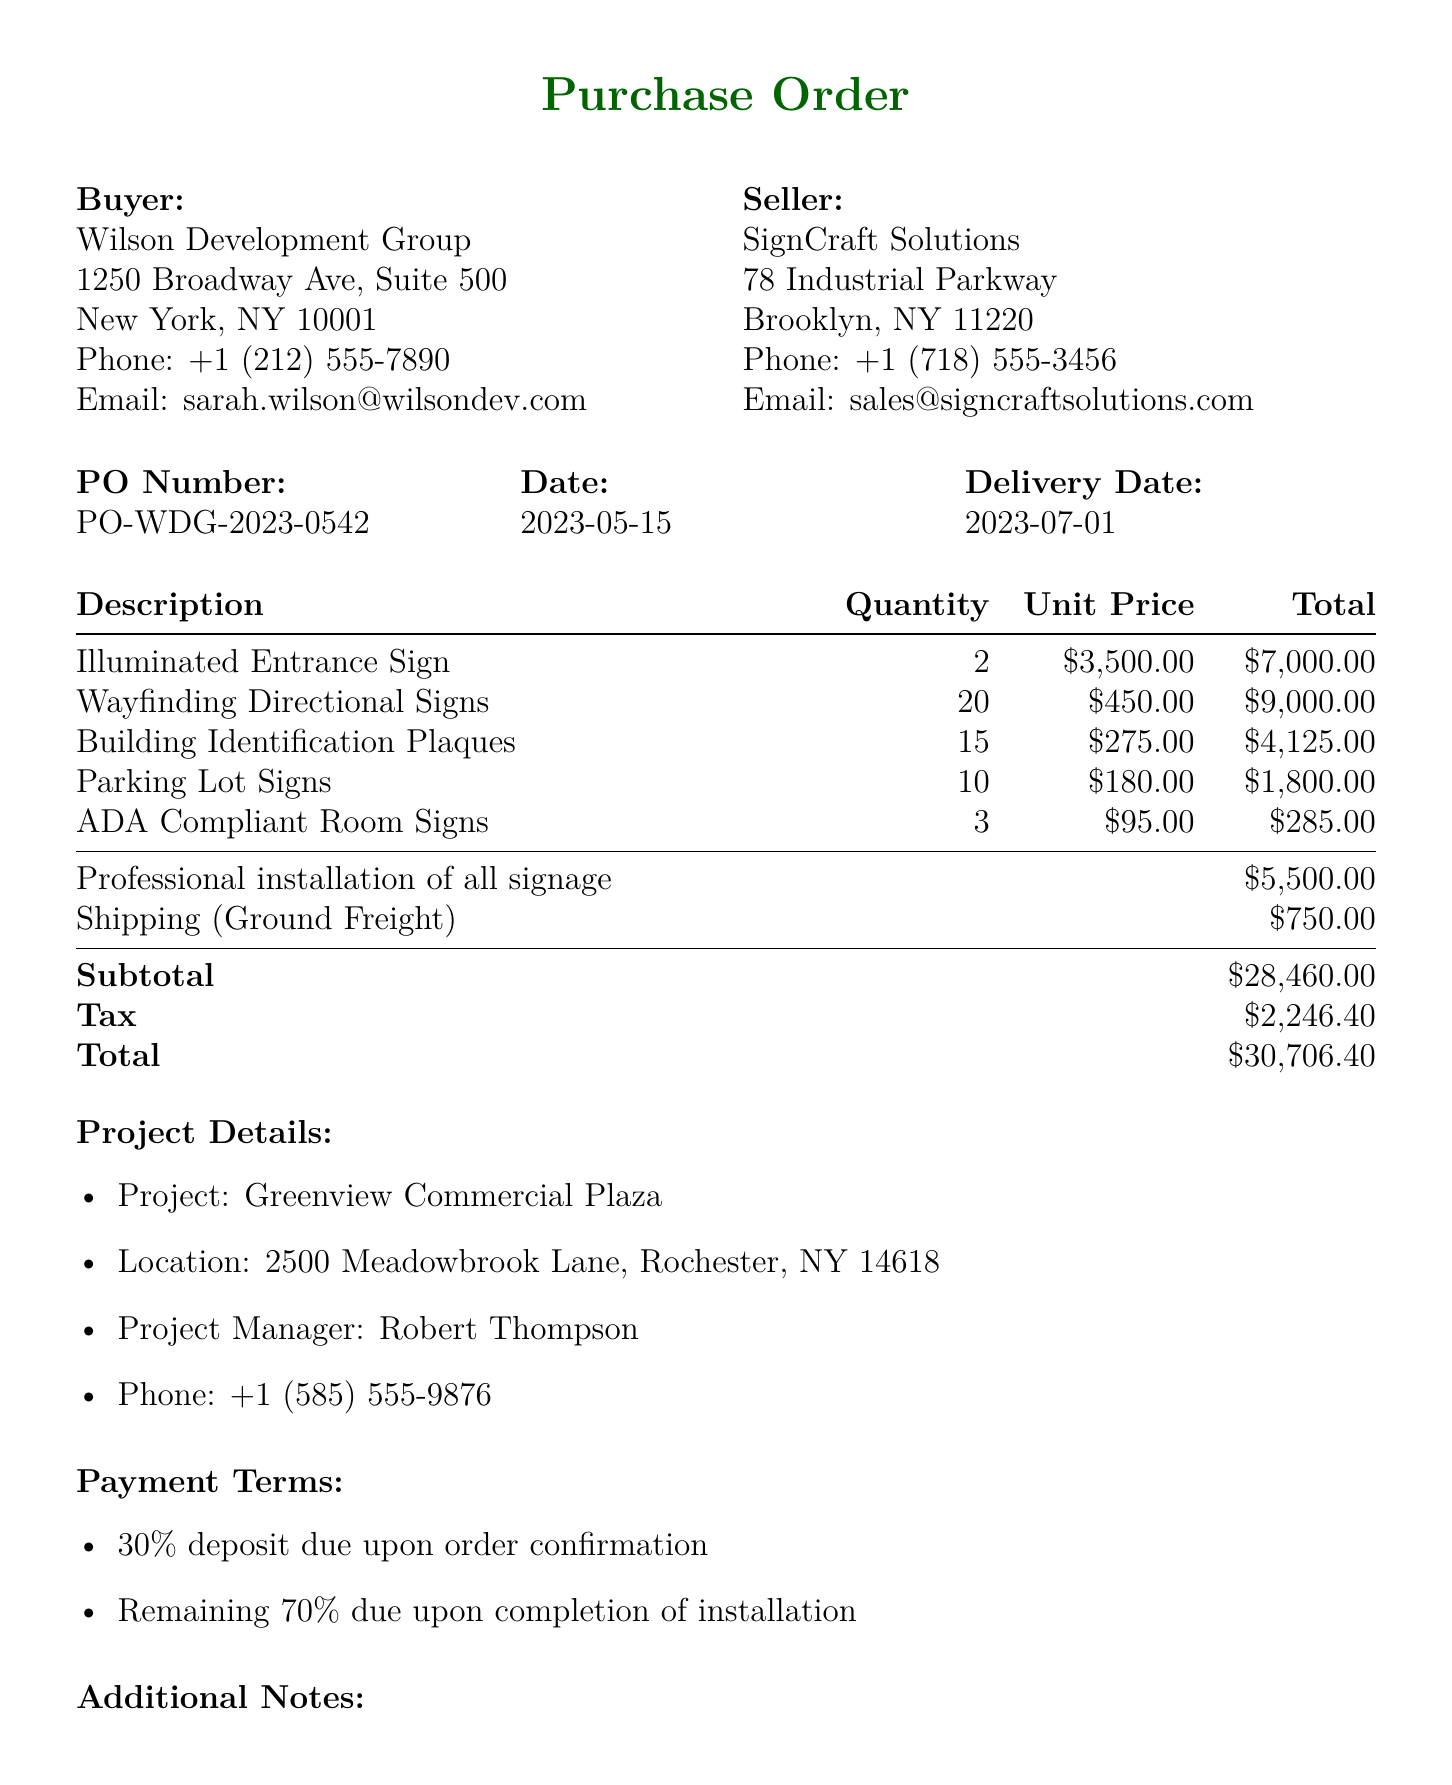What is the name of the buyer? The buyer's name is listed in the document under the buyer section.
Answer: Wilson Development Group What is the purchase order number? The purchase order number is clearly stated in the order details section.
Answer: PO-WDG-2023-0542 What is the total amount due? The total amount is calculated at the end of the document.
Answer: $30,706.40 How many Wayfinding Directional Signs were ordered? The quantity of Wayfinding Directional Signs is specified in the items list.
Answer: 20 What percentage of the total cost is due as a deposit? The payment terms specify the percentage due upon order confirmation.
Answer: 30% What is the delivery date? The delivery date is mentioned in the order details section.
Answer: 2023-07-01 Who is the project manager for the commercial development? The project manager's name is included in the project details section.
Answer: Robert Thompson What is the shipping cost for the order? The shipping cost is listed separately in the total costs section.
Answer: $750 What type of signs are required to comply with local zoning regulations? This requirement is noted in the additional notes section of the document.
Answer: All signage 